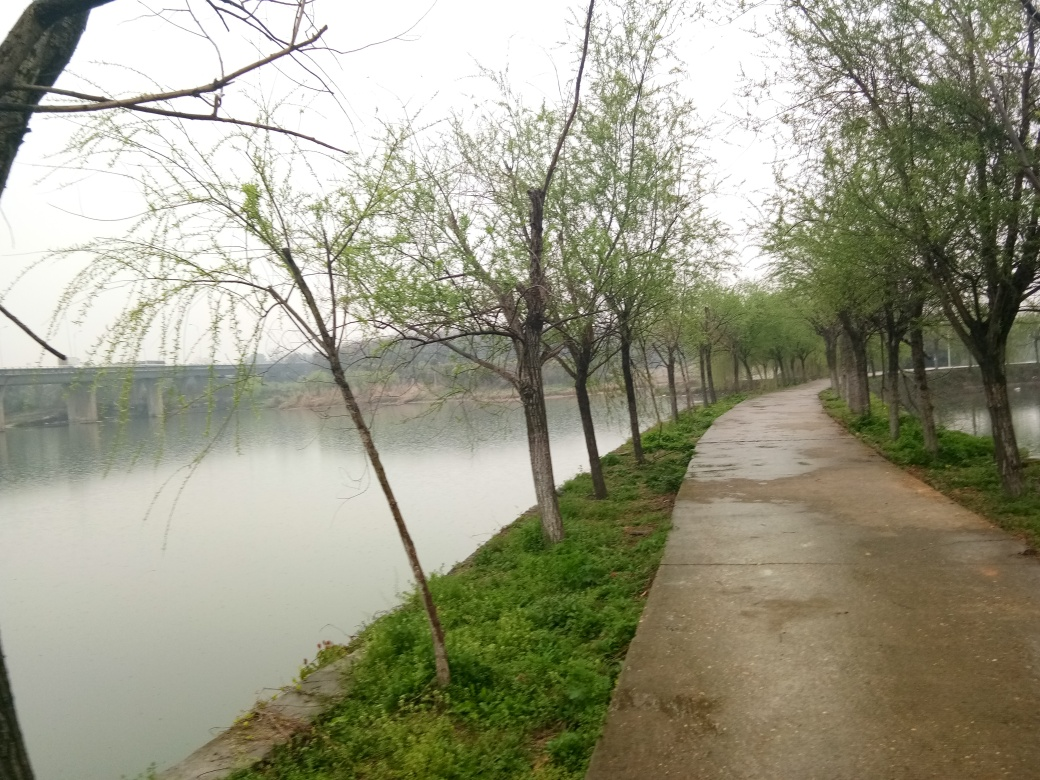Can you describe the atmosphere of the location captured in the image? The atmosphere of the location is tranquil and slightly melancholic. The overcast sky, the quietness implied by the empty path, and the lush greenery beginning to emerge create a peaceful and contemplative mood, inviting reflection or solitary repose. 